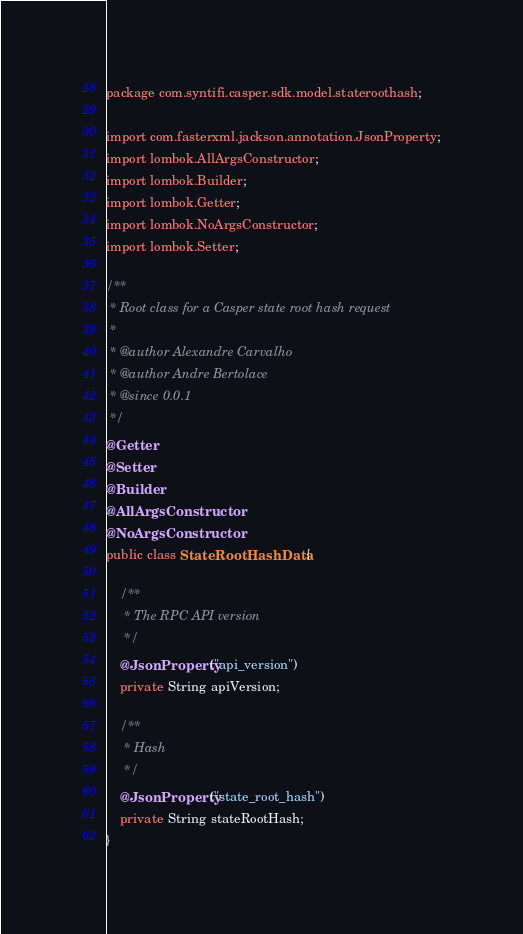Convert code to text. <code><loc_0><loc_0><loc_500><loc_500><_Java_>package com.syntifi.casper.sdk.model.stateroothash;

import com.fasterxml.jackson.annotation.JsonProperty;
import lombok.AllArgsConstructor;
import lombok.Builder;
import lombok.Getter;
import lombok.NoArgsConstructor;
import lombok.Setter;

/**
 * Root class for a Casper state root hash request
 *
 * @author Alexandre Carvalho
 * @author Andre Bertolace
 * @since 0.0.1
 */
@Getter
@Setter
@Builder
@AllArgsConstructor
@NoArgsConstructor
public class StateRootHashData {

    /**
     * The RPC API version
     */
    @JsonProperty("api_version")
    private String apiVersion;

    /**
     * Hash
     */
    @JsonProperty("state_root_hash")
    private String stateRootHash;
}</code> 